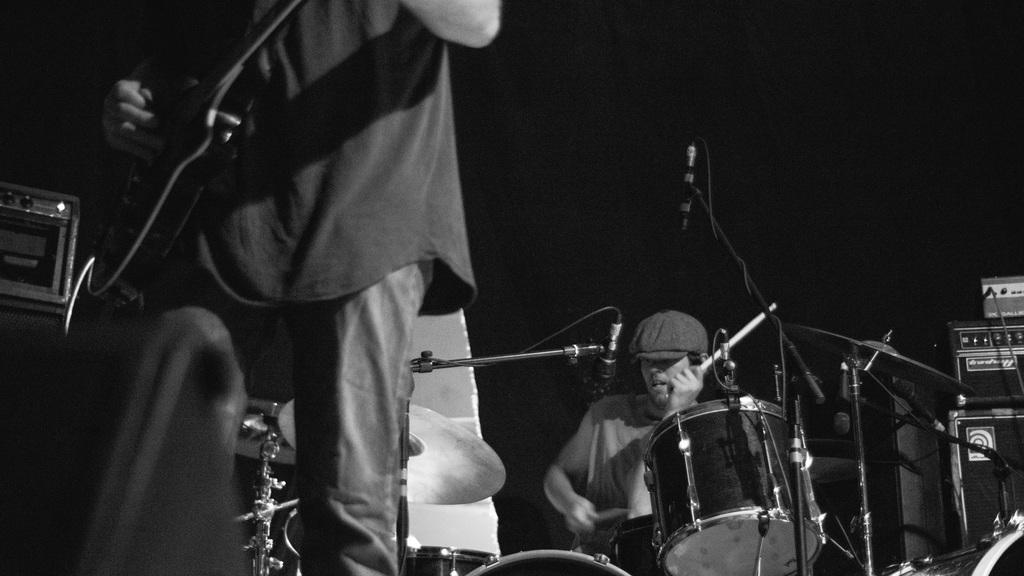What is the person holding in the image? The person is holding a microphone in the image. What is the person doing with the microphone? The person is playing the microphone. What else can be seen in the image besides the person with the microphone? There are musical instruments in the image. Can you describe the person who is standing and holding an instrument? There is a person standing and holding an instrument in the image. What type of toy can be seen on the scale in the image? There is no toy or scale present in the image. How does the person holding the microphone know what time it is? The image does not provide any information about the time, so it cannot be determined from the image. 